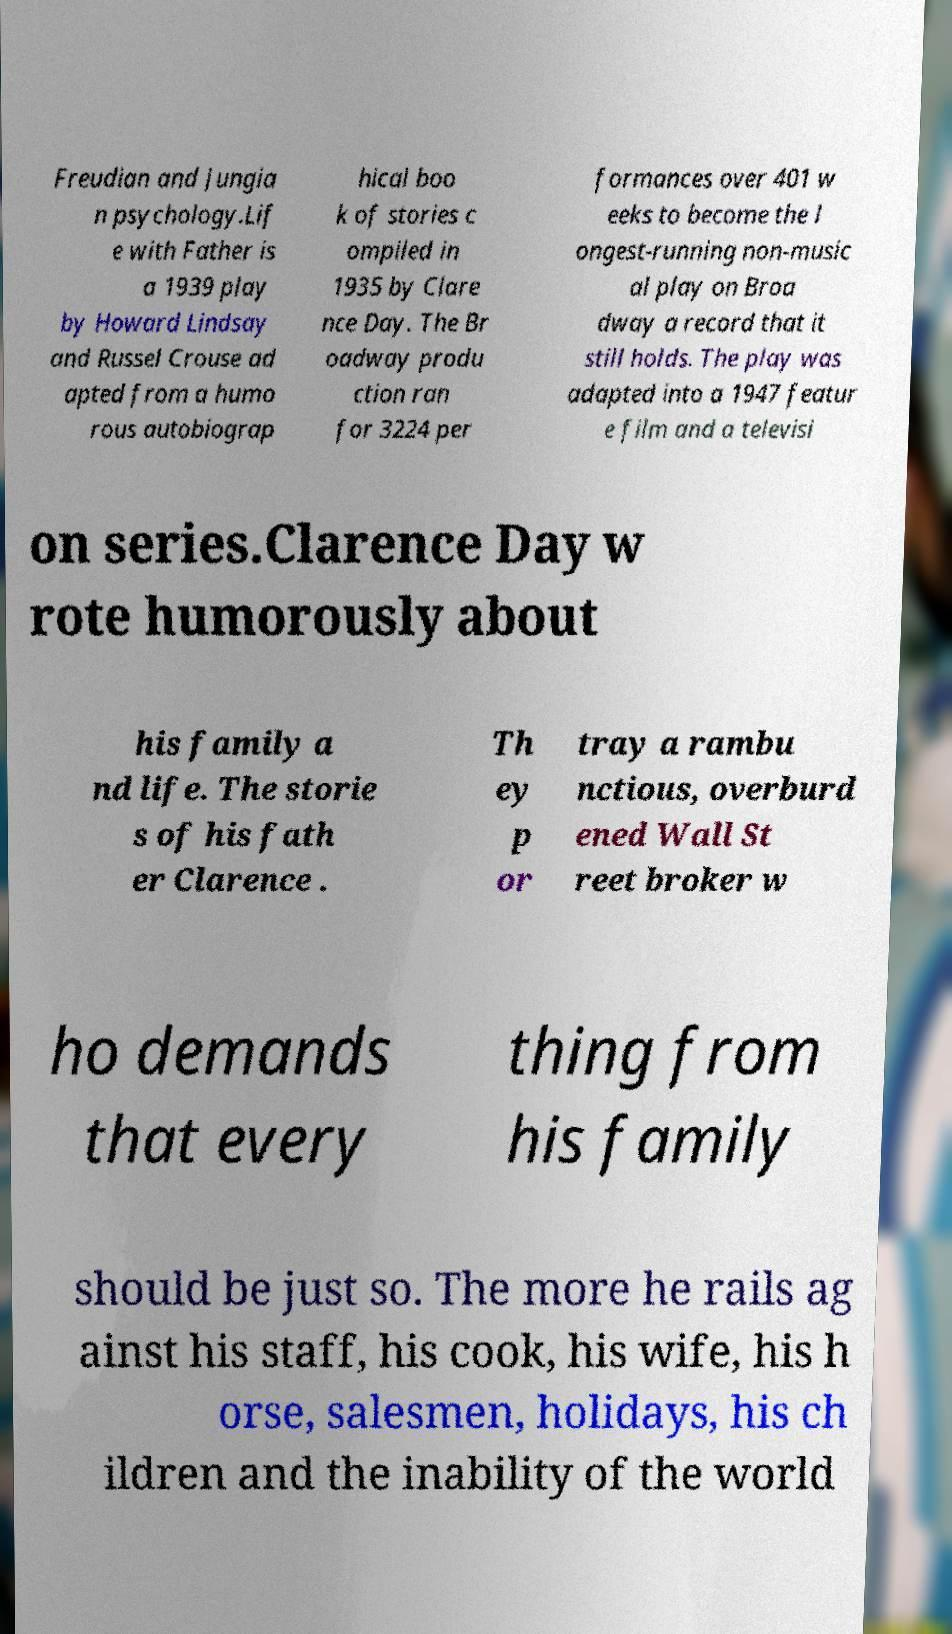What messages or text are displayed in this image? I need them in a readable, typed format. Freudian and Jungia n psychology.Lif e with Father is a 1939 play by Howard Lindsay and Russel Crouse ad apted from a humo rous autobiograp hical boo k of stories c ompiled in 1935 by Clare nce Day. The Br oadway produ ction ran for 3224 per formances over 401 w eeks to become the l ongest-running non-music al play on Broa dway a record that it still holds. The play was adapted into a 1947 featur e film and a televisi on series.Clarence Day w rote humorously about his family a nd life. The storie s of his fath er Clarence . Th ey p or tray a rambu nctious, overburd ened Wall St reet broker w ho demands that every thing from his family should be just so. The more he rails ag ainst his staff, his cook, his wife, his h orse, salesmen, holidays, his ch ildren and the inability of the world 